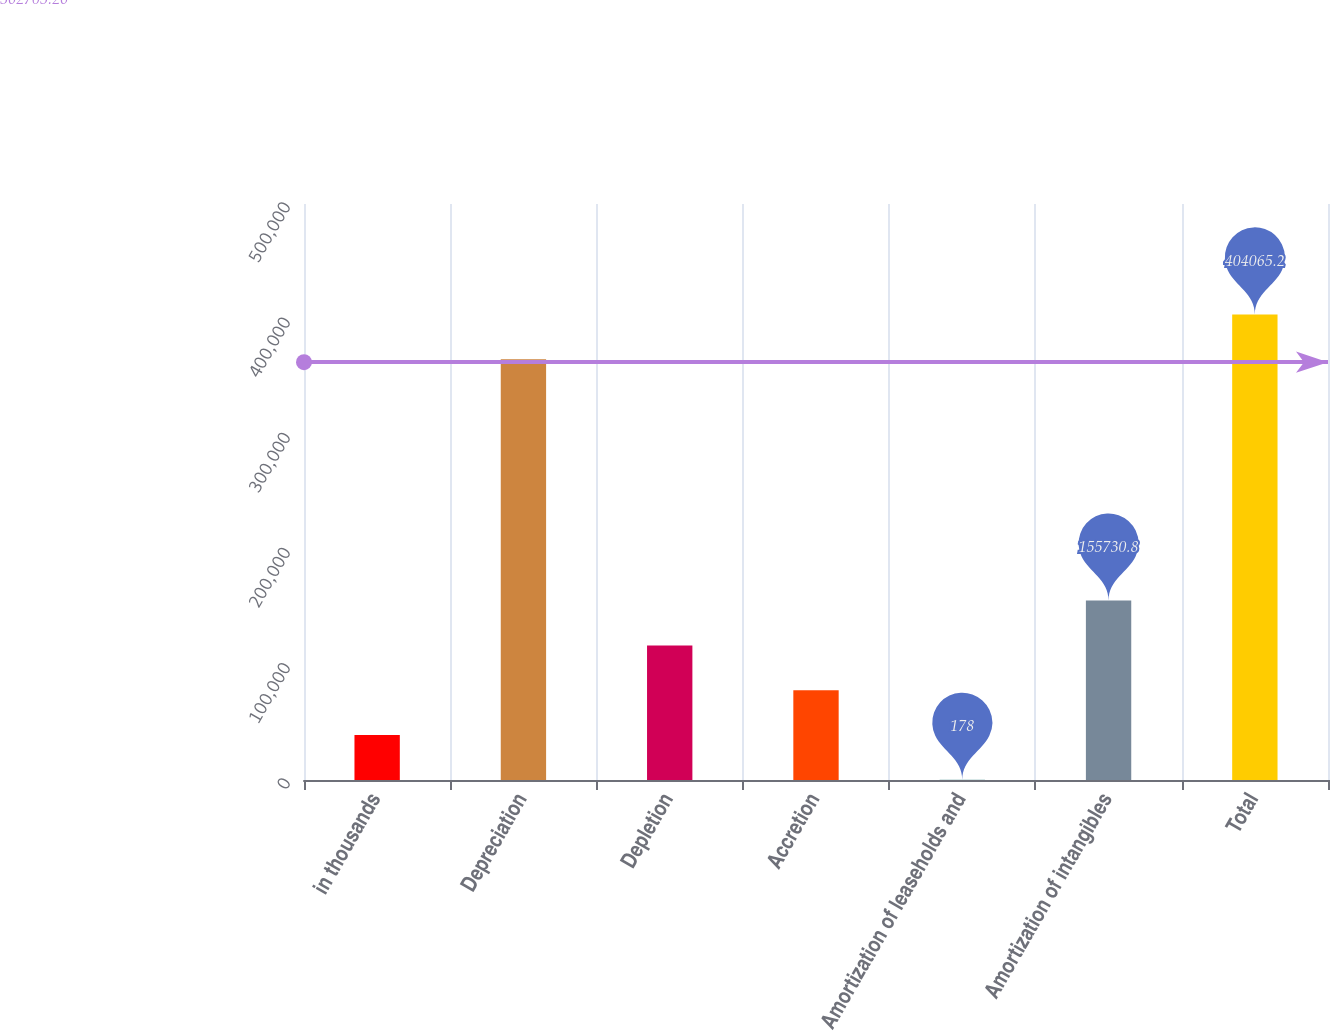<chart> <loc_0><loc_0><loc_500><loc_500><bar_chart><fcel>in thousands<fcel>Depreciation<fcel>Depletion<fcel>Accretion<fcel>Amortization of leaseholds and<fcel>Amortization of intangibles<fcel>Total<nl><fcel>39066.2<fcel>365177<fcel>116843<fcel>77954.4<fcel>178<fcel>155731<fcel>404065<nl></chart> 